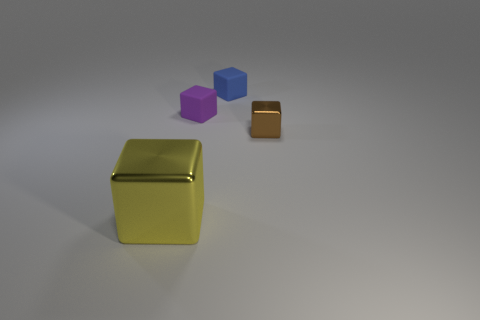There is a cube to the right of the blue object; what is it made of?
Provide a short and direct response. Metal. How many small objects are matte things or yellow cubes?
Ensure brevity in your answer.  2. What color is the big metallic block?
Your response must be concise. Yellow. There is a metallic object behind the large block; is there a big shiny cube to the right of it?
Provide a succinct answer. No. Are there fewer small rubber cubes on the left side of the tiny blue rubber thing than tiny purple blocks?
Your response must be concise. No. Is the tiny blue thing behind the small purple cube made of the same material as the large cube?
Your response must be concise. No. There is a large block that is the same material as the tiny brown block; what color is it?
Offer a very short reply. Yellow. Are there fewer tiny brown objects left of the yellow metal cube than shiny objects left of the small blue block?
Give a very brief answer. Yes. There is a metallic block that is on the right side of the big yellow metal cube; is its color the same as the block that is to the left of the purple thing?
Provide a short and direct response. No. Is there a red thing made of the same material as the large cube?
Make the answer very short. No. 